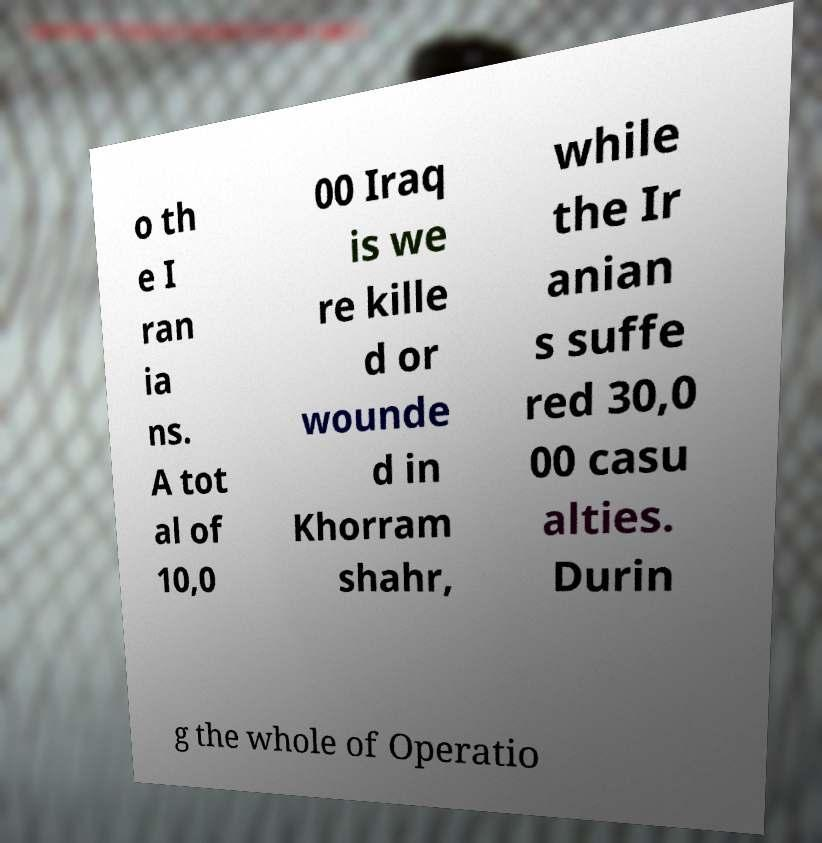Could you extract and type out the text from this image? o th e I ran ia ns. A tot al of 10,0 00 Iraq is we re kille d or wounde d in Khorram shahr, while the Ir anian s suffe red 30,0 00 casu alties. Durin g the whole of Operatio 